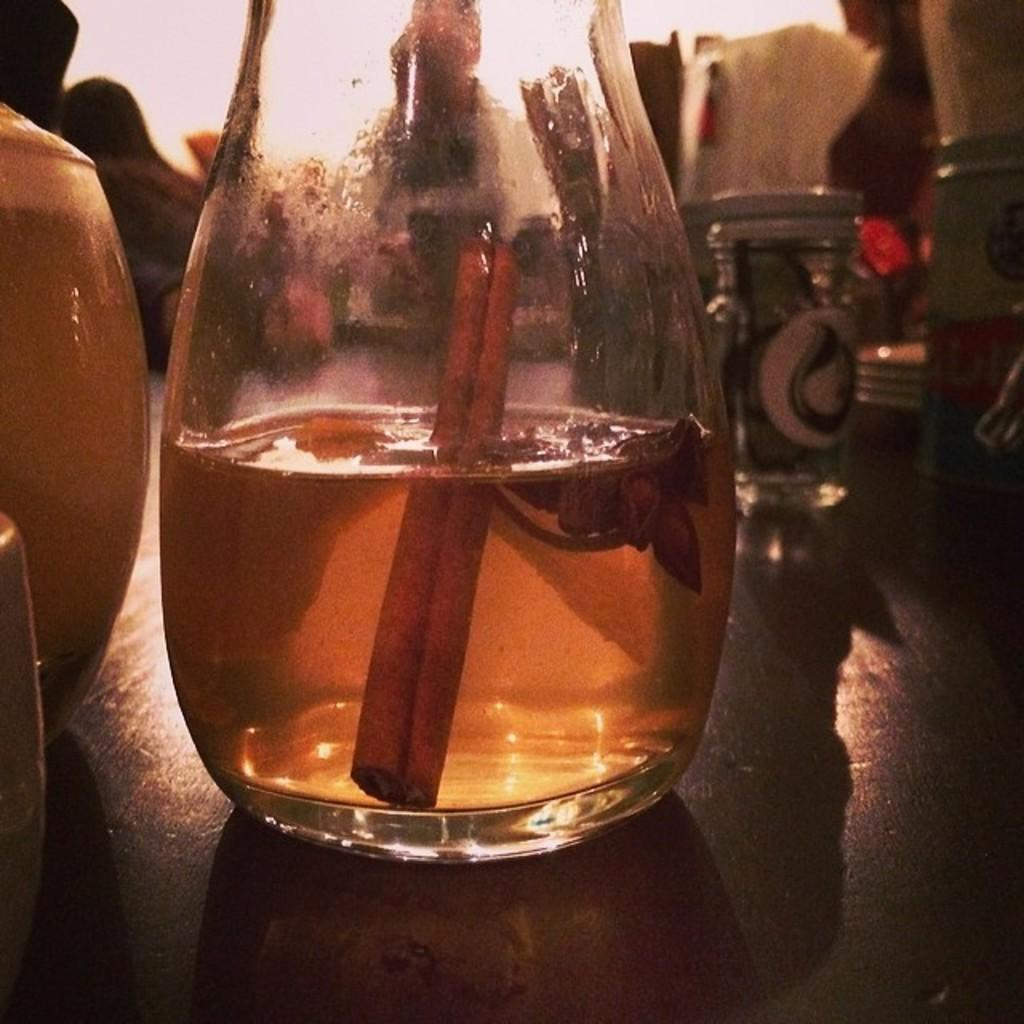What object is present in the image that contains a liquid? There is a glass jar in the image. What is inside the glass jar? There is a dissolved solution in the glass jar. How many pies are being requested in the image? There is no mention of pies or a request for pies in the image. 